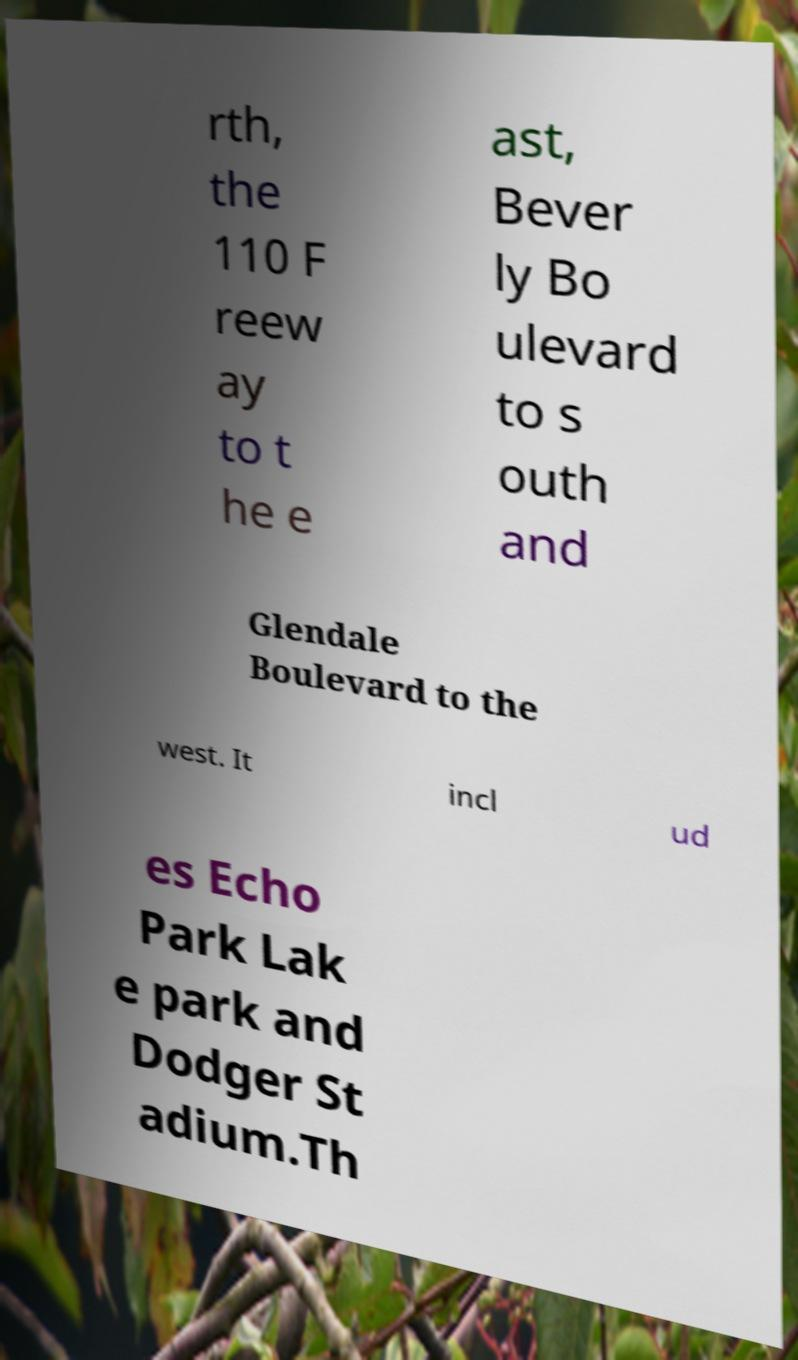Please read and relay the text visible in this image. What does it say? rth, the 110 F reew ay to t he e ast, Bever ly Bo ulevard to s outh and Glendale Boulevard to the west. It incl ud es Echo Park Lak e park and Dodger St adium.Th 